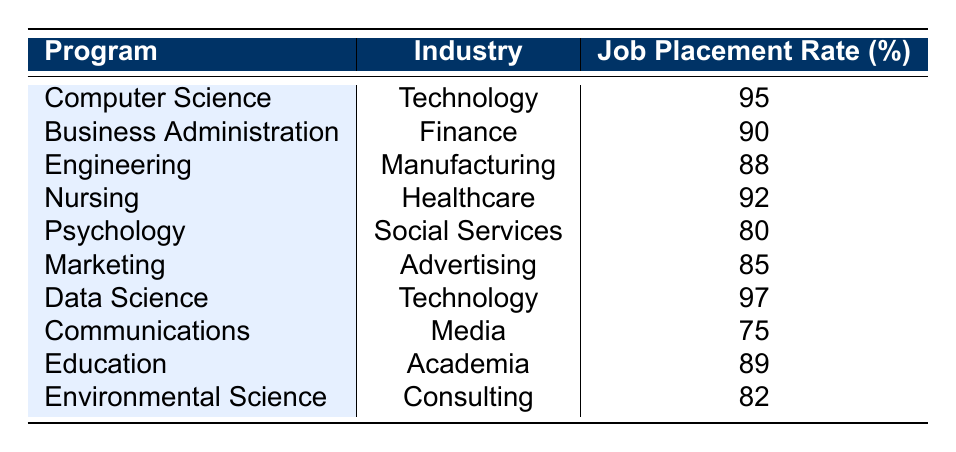What is the job placement rate for Computer Science? The job placement rate for Computer Science can be found in the row for that program. It shows 95%.
Answer: 95% Which program has the highest job placement rate? By comparing the job placement rates of all programs, Data Science has the highest placement rate at 97%.
Answer: Data Science Is the job placement rate for Nursing higher than that of Marketing? The job placement rate for Nursing is 92% and for Marketing is 85%. Since 92% is higher than 85%, the answer is yes.
Answer: Yes What is the average job placement rate across all programs listed? To find the average, we sum all the job placement rates: 95 + 90 + 88 + 92 + 80 + 85 + 97 + 75 + 89 + 82 = 908. Then divide by the number of programs, which is 10. 908/10 = 90.8.
Answer: 90.8 Does any program in the table list a job placement rate below 80%? The lowest job placement rate in the table is 75%, which belongs to Communications. Therefore, there is indeed a program below 80%.
Answer: Yes What is the difference between the job placement rates for Engineering and Environmental Science? The job placement rate for Engineering is 88% and for Environmental Science is 82%. The difference is calculated as 88 - 82 = 6.
Answer: 6 Which industries have a job placement rate above 90%? Looking at the job placement rates, Technology (95% and 97%), Finance (90%), and Healthcare (92%) have rates above 90%.
Answer: Technology, Finance, Healthcare Is the job placement rate for Psychology greater than that for Education? The job placement rate for Psychology is 80% and for Education is 89%. Since 80% is not greater than 89%, the answer is no.
Answer: No What percentage of programs listed have a job placement rate above 90%? There are 4 programs (Computer Science, Data Science, Nursing, and Finance) with rates above 90%. Since there are 10 programs, the percentage is (4/10) * 100 = 40%.
Answer: 40% 